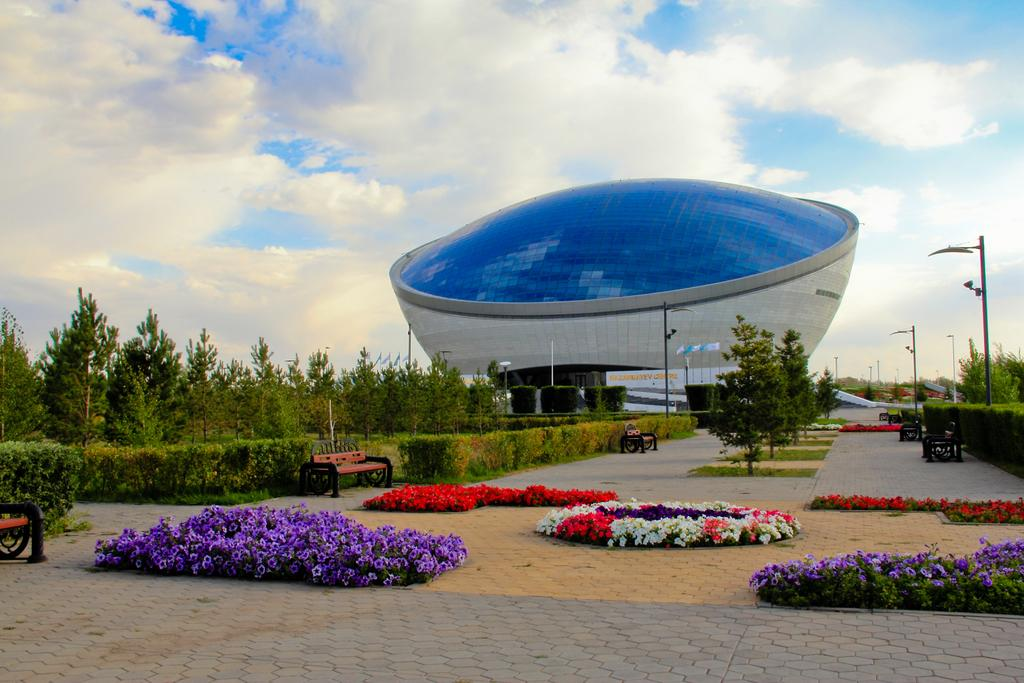What type of vegetation can be seen in the image? There are flowers, plants, and trees in the image. What type of seating is available in the image? There are benches in the image. What type of infrastructure is present in the image? There are current poles in the image. What is visible at the top of the image? The sky is visible at the top of the image. What can be seen in the sky? Clouds are present in the sky. Is there a window visible in the image? There is no window present in the image. What type of power source is being used by the current poles in the image? The image does not provide information about the power source being used by the current poles. 